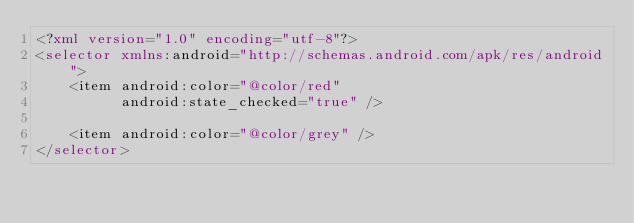<code> <loc_0><loc_0><loc_500><loc_500><_XML_><?xml version="1.0" encoding="utf-8"?>
<selector xmlns:android="http://schemas.android.com/apk/res/android">
    <item android:color="@color/red"
          android:state_checked="true" />

    <item android:color="@color/grey" />
</selector></code> 